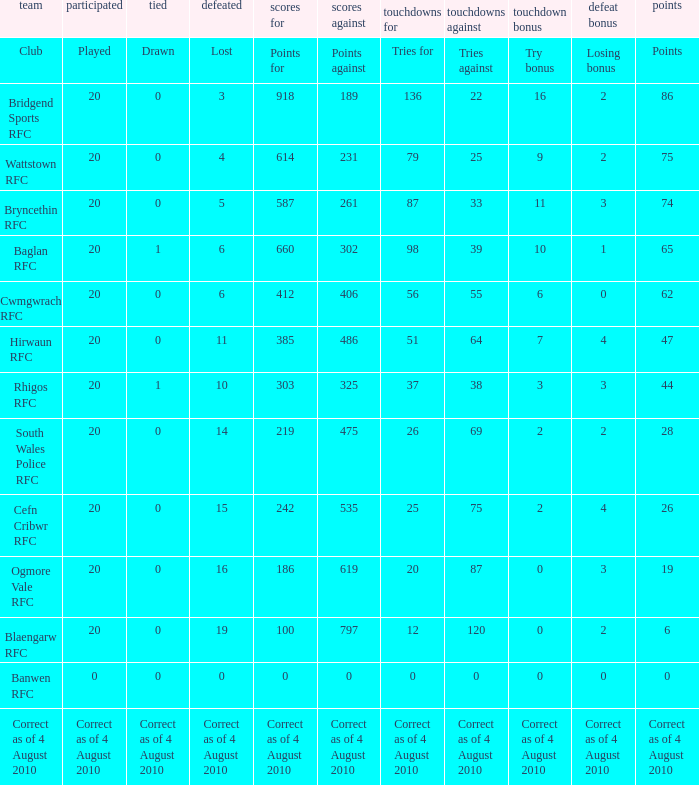What is the loss when the points against reach 231? 4.0. 